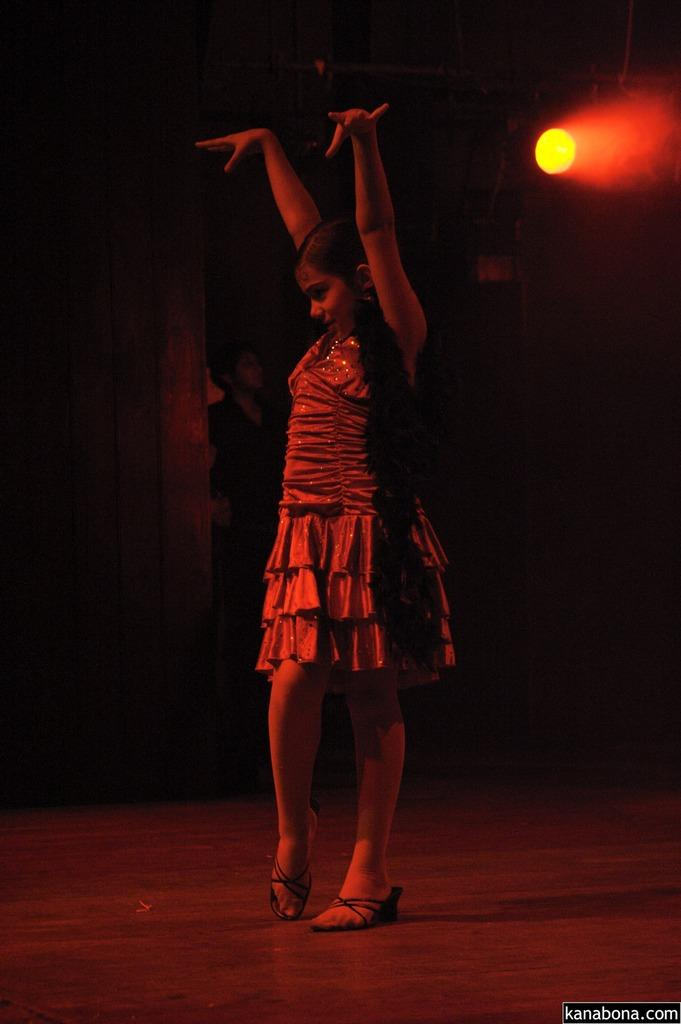What is the main subject of the image? There is a girl standing in the image. Can you describe any objects or features in the image? There is a light in the image. How would you describe the overall appearance of the background? The background of the image is a mix of light and dark areas. Is there any text present in the image? Yes, there is text at the bottom right corner of the image. How many spiders are crawling on the girl in the image? There are no spiders present in the image; the girl is standing alone. What type of map is visible in the image? There is no map present in the image. 